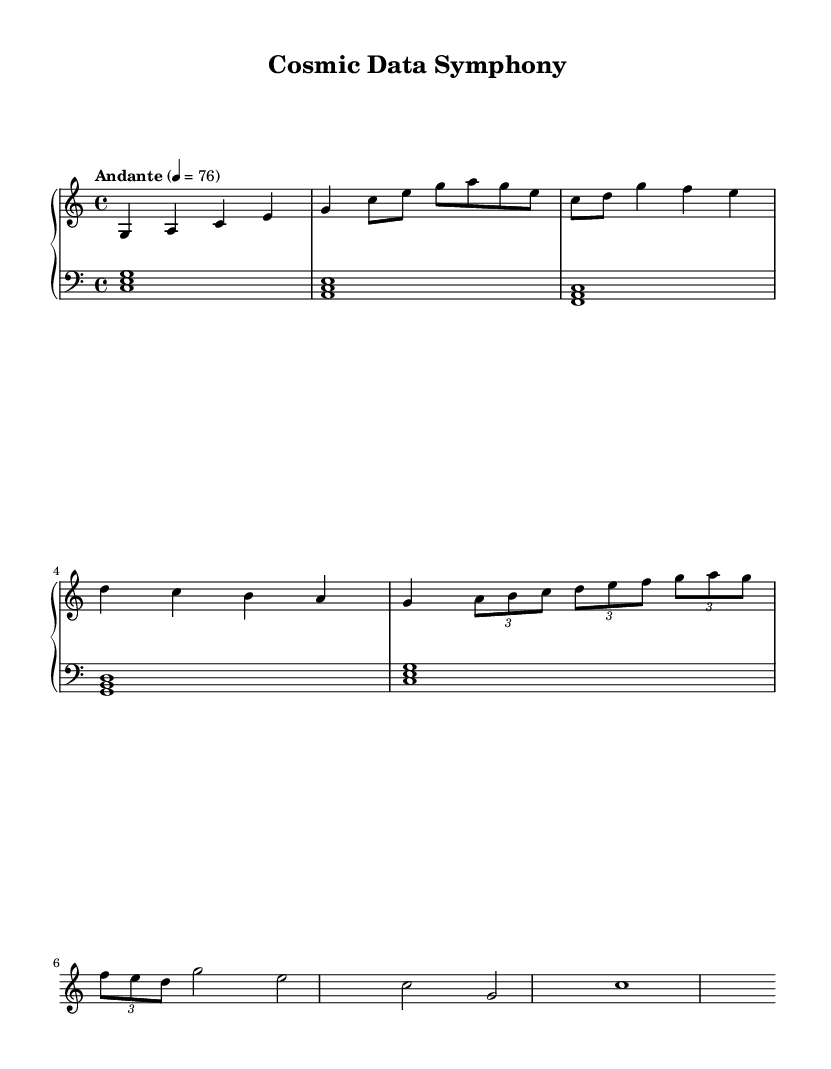What is the key signature of this music? The key signature is indicated at the beginning of the score. Here, it shows "c" which corresponds to C major, meaning there are no sharps or flats.
Answer: C major What is the time signature of this music? The time signature is shown at the beginning of the score as "4/4". This indicates that there are four beats per measure, and the quarter note gets one beat.
Answer: 4/4 What is the tempo marking of this music? The tempo is given in the header, specifically "Andante" with a metronome marking of 76 beats per minute. "Andante" suggests a moderately slow tempo.
Answer: Andante 4 = 76 How many measures are in the piano part? A measure can be identified by vertical lines on the staff. By counting these groupings for the piano part, we note that there are a total of 8 measures present in the score.
Answer: 8 Which section includes a tuplets? By examining the music, we find that the bridge section includes tuplets, denoted by the time notation (3/2) and the grouping of notes. This distinguishes it from the other sections that follow the standard time.
Answer: Bridge What chords are played in the bass throughout the piece? The bass part consists of consistently played triads for each section. By examining the score, the correct chords are identified as C major, A minor, F major, G major, and again C major, reflecting a typical harmonic progression.
Answer: C, A, F, G What is the last note of the piano part? The final note of the piece is visually checked from the score, revealing that the last note in the piano part is a whole note "c" following the final chord progression in the outro.
Answer: c 